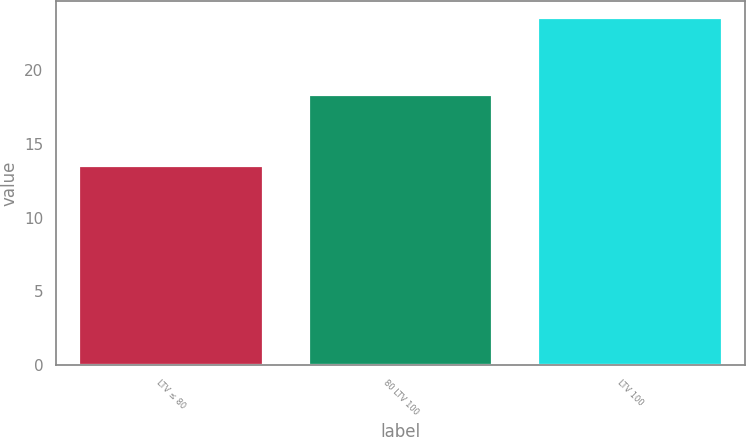Convert chart. <chart><loc_0><loc_0><loc_500><loc_500><bar_chart><fcel>LTV ≤ 80<fcel>80 LTV 100<fcel>LTV 100<nl><fcel>13.5<fcel>18.3<fcel>23.5<nl></chart> 